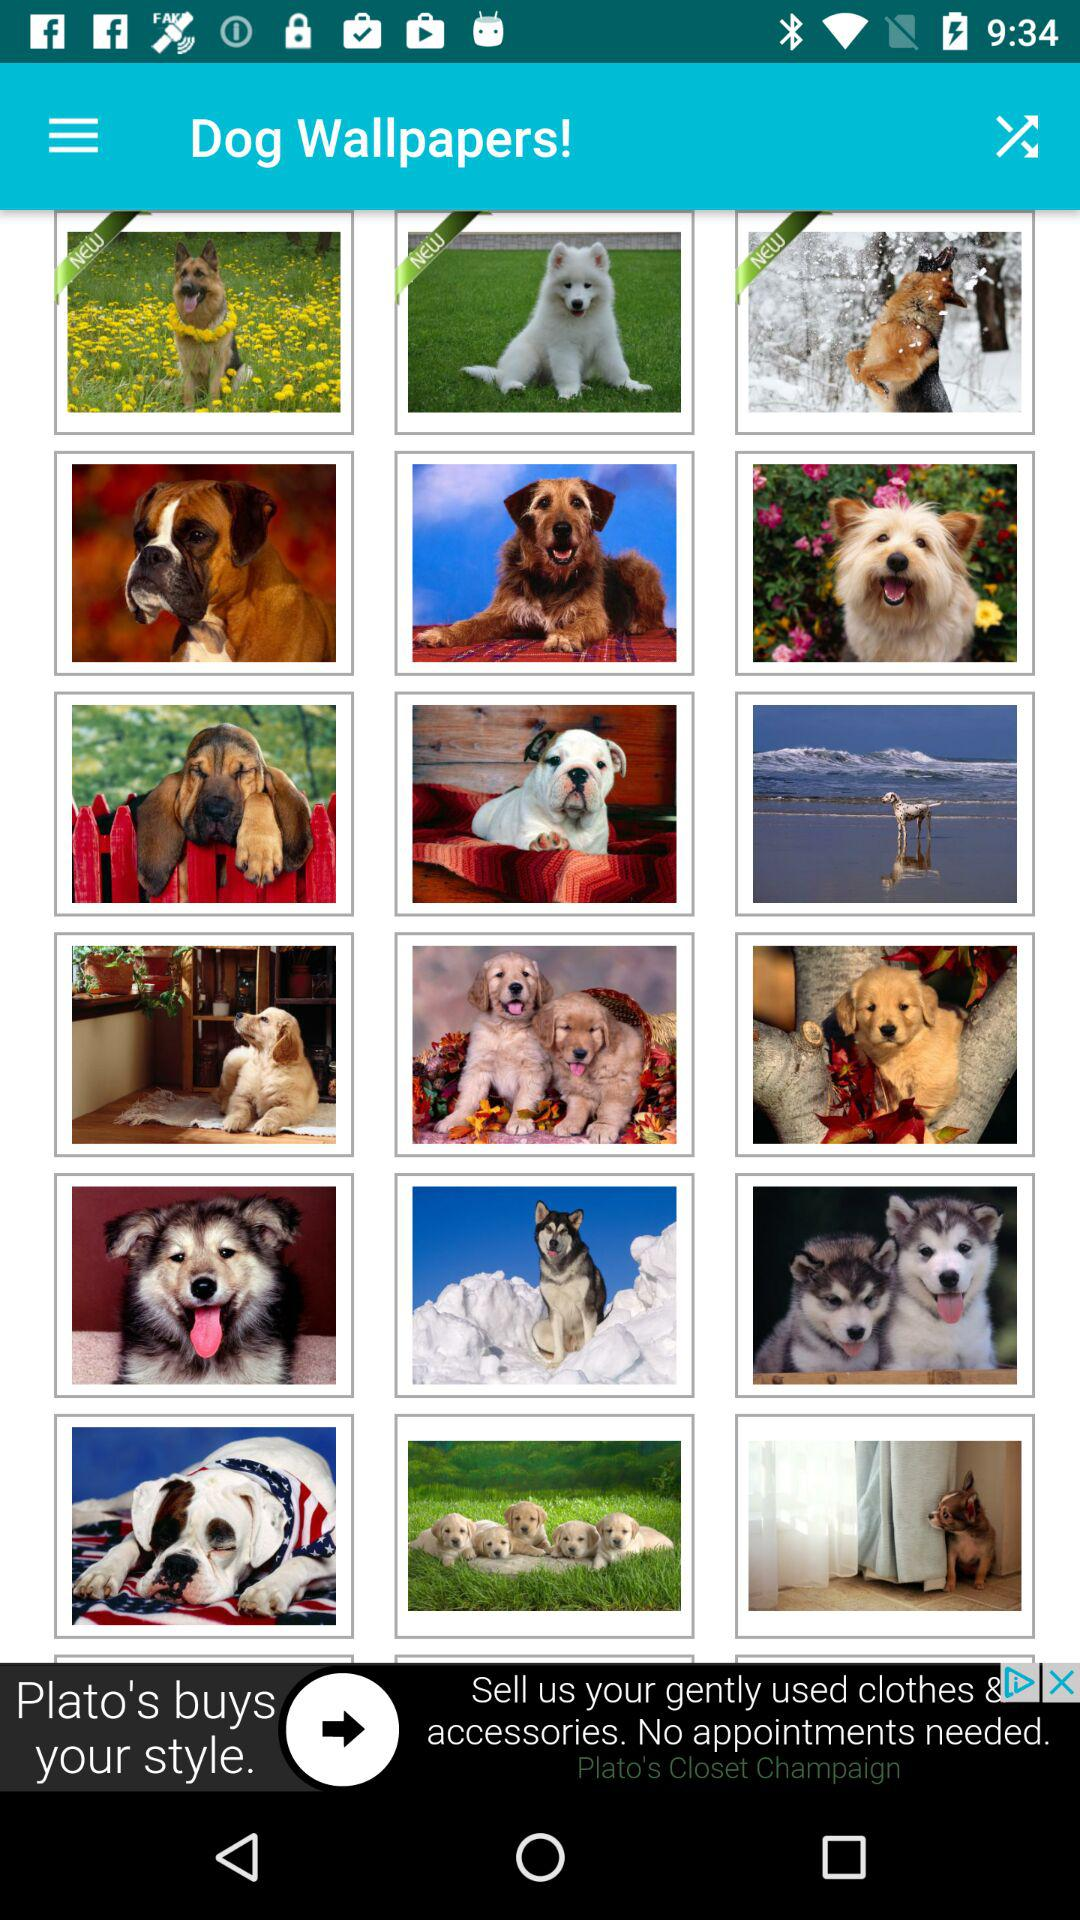What is the application name? The application name is "Dog Wallpapers!". 